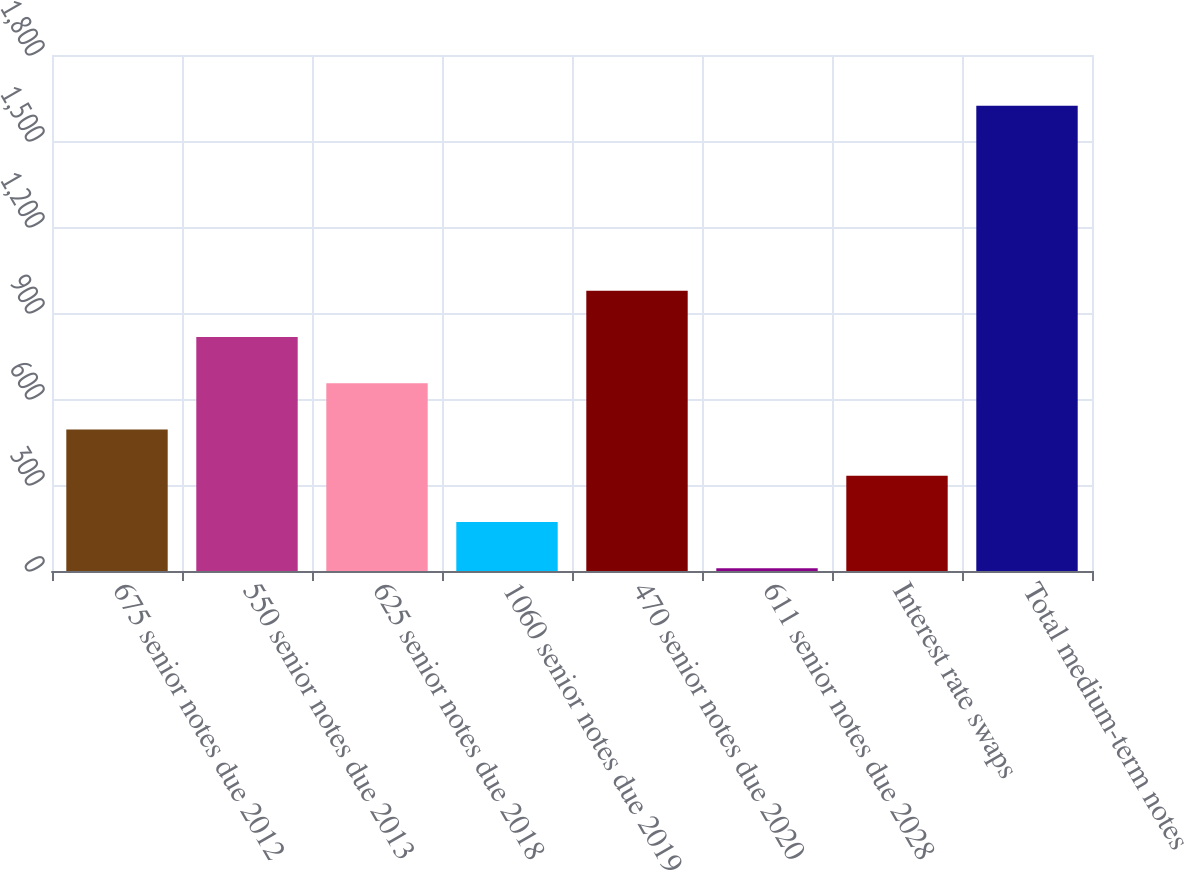Convert chart. <chart><loc_0><loc_0><loc_500><loc_500><bar_chart><fcel>675 senior notes due 2012<fcel>550 senior notes due 2013<fcel>625 senior notes due 2018<fcel>1060 senior notes due 2019<fcel>470 senior notes due 2020<fcel>611 senior notes due 2028<fcel>Interest rate swaps<fcel>Total medium-term notes<nl><fcel>493.9<fcel>816.5<fcel>655.2<fcel>171.3<fcel>977.8<fcel>10<fcel>332.6<fcel>1623<nl></chart> 